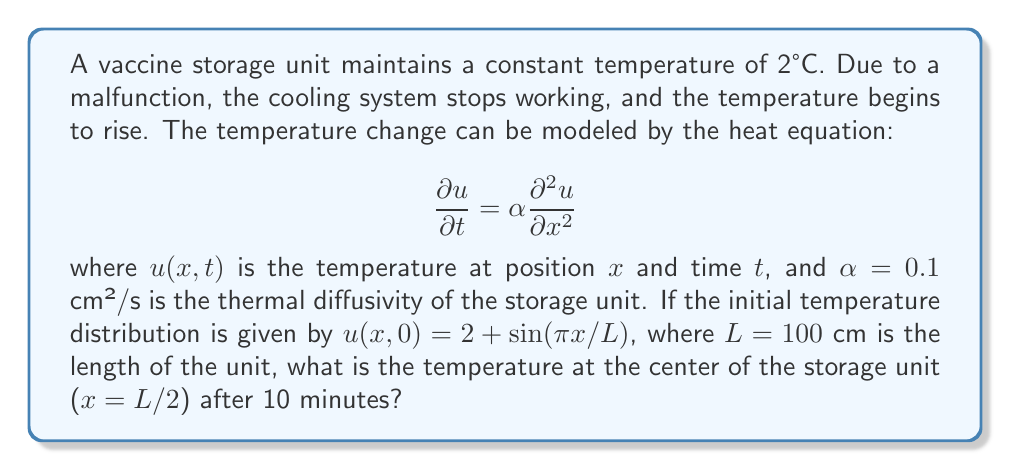Solve this math problem. To solve this problem, we need to use the solution to the heat equation with the given initial conditions. The general solution for this type of problem is:

$$u(x,t) = 2 + \sin(\frac{\pi x}{L})e^{-\alpha(\frac{\pi}{L})^2t}$$

Let's follow these steps:

1) First, we need to convert the time from minutes to seconds:
   10 minutes = 600 seconds

2) Now, let's substitute the values into the equation:
   $\alpha = 0.1$ cm²/s
   $L = 100$ cm
   $x = L/2 = 50$ cm (center of the unit)
   $t = 600$ s

3) Let's calculate $(\frac{\pi}{L})^2$:
   $(\frac{\pi}{100})^2 = 0.000986960440109$

4) Now we can substitute everything into the equation:

   $$u(50,600) = 2 + \sin(\frac{\pi 50}{100})e^{-0.1 \cdot 0.000986960440109 \cdot 600}$$

5) Simplify:
   $$u(50,600) = 2 + \sin(\frac{\pi}{2})e^{-0.05921762640654}$$

6) Calculate:
   $\sin(\frac{\pi}{2}) = 1$
   $e^{-0.05921762640654} \approx 0.9424778$

7) Final calculation:
   $$u(50,600) = 2 + 1 \cdot 0.9424778 \approx 2.9424778$$

Therefore, the temperature at the center of the storage unit after 10 minutes is approximately 2.94°C.
Answer: 2.94°C 